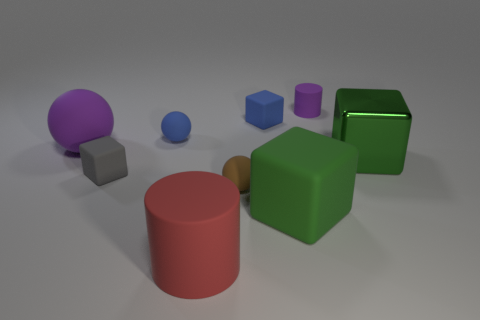Add 1 shiny things. How many objects exist? 10 Subtract all purple rubber balls. How many balls are left? 2 Subtract all cylinders. How many objects are left? 7 Subtract all blue cylinders. Subtract all yellow spheres. How many cylinders are left? 2 Subtract all cyan blocks. How many purple balls are left? 1 Subtract all shiny cubes. Subtract all purple rubber cubes. How many objects are left? 8 Add 6 big green things. How many big green things are left? 8 Add 2 big red shiny cubes. How many big red shiny cubes exist? 2 Subtract all purple cylinders. How many cylinders are left? 1 Subtract 0 green spheres. How many objects are left? 9 